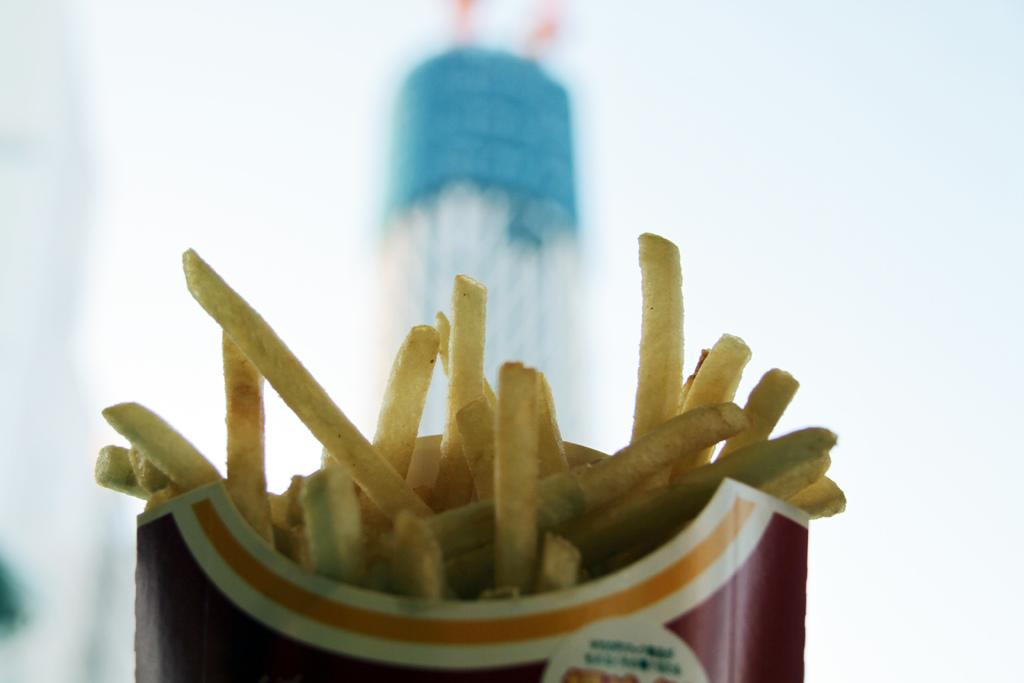What object is the main focus of the image? There is a box in the image. What is inside the box? The box contains french fries. Can you describe the background of the image? The background of the image is blurred. What type of balls can be seen bouncing in the background of the image? There are no balls present in the image, and the background is blurred, so it is not possible to see any balls bouncing. 